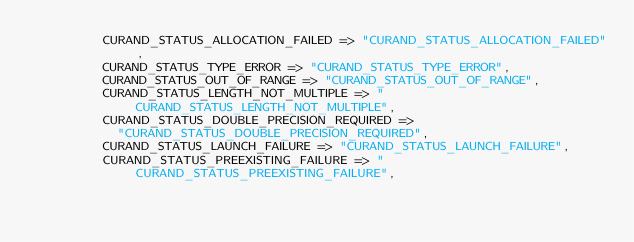<code> <loc_0><loc_0><loc_500><loc_500><_Julia_>         CURAND_STATUS_ALLOCATION_FAILED => "CURAND_STATUS_ALLOCATION_FAILED",
         CURAND_STATUS_TYPE_ERROR => "CURAND_STATUS_TYPE_ERROR",
         CURAND_STATUS_OUT_OF_RANGE => "CURAND_STATUS_OUT_OF_RANGE",
         CURAND_STATUS_LENGTH_NOT_MULTIPLE => "CURAND_STATUS_LENGTH_NOT_MULTIPLE",
         CURAND_STATUS_DOUBLE_PRECISION_REQUIRED =>
           "CURAND_STATUS_DOUBLE_PRECISION_REQUIRED",
         CURAND_STATUS_LAUNCH_FAILURE => "CURAND_STATUS_LAUNCH_FAILURE",
         CURAND_STATUS_PREEXISTING_FAILURE => "CURAND_STATUS_PREEXISTING_FAILURE",</code> 